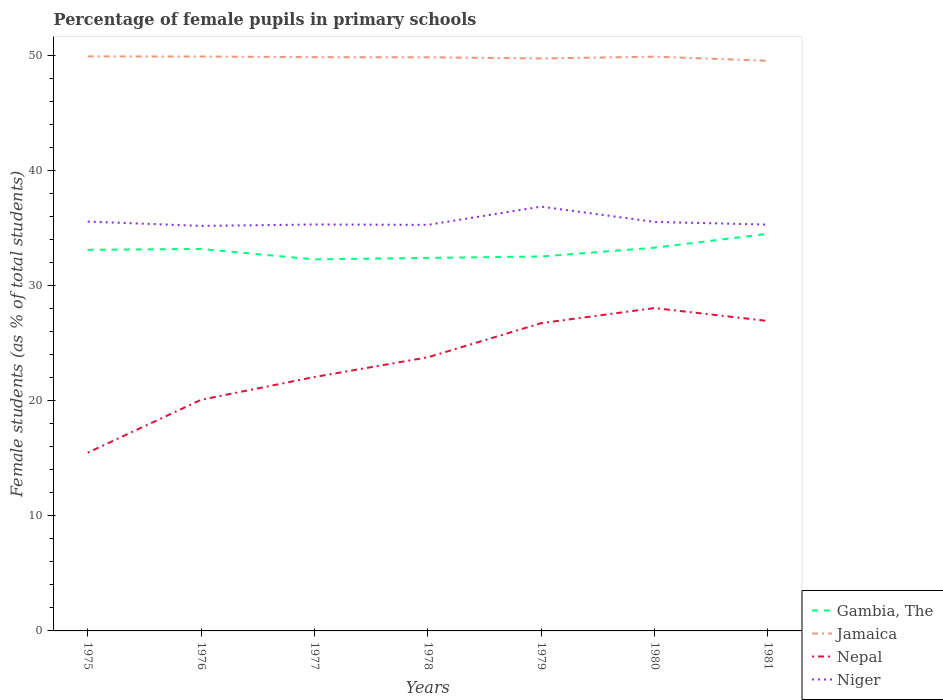Does the line corresponding to Jamaica intersect with the line corresponding to Gambia, The?
Give a very brief answer. No. Is the number of lines equal to the number of legend labels?
Make the answer very short. Yes. Across all years, what is the maximum percentage of female pupils in primary schools in Nepal?
Keep it short and to the point. 15.48. In which year was the percentage of female pupils in primary schools in Niger maximum?
Make the answer very short. 1976. What is the total percentage of female pupils in primary schools in Jamaica in the graph?
Keep it short and to the point. 0.32. What is the difference between the highest and the second highest percentage of female pupils in primary schools in Niger?
Your answer should be very brief. 1.67. How many lines are there?
Make the answer very short. 4. How many years are there in the graph?
Provide a short and direct response. 7. What is the difference between two consecutive major ticks on the Y-axis?
Your response must be concise. 10. Are the values on the major ticks of Y-axis written in scientific E-notation?
Give a very brief answer. No. How many legend labels are there?
Provide a succinct answer. 4. How are the legend labels stacked?
Give a very brief answer. Vertical. What is the title of the graph?
Give a very brief answer. Percentage of female pupils in primary schools. What is the label or title of the X-axis?
Give a very brief answer. Years. What is the label or title of the Y-axis?
Make the answer very short. Female students (as % of total students). What is the Female students (as % of total students) in Gambia, The in 1975?
Offer a very short reply. 33.11. What is the Female students (as % of total students) in Jamaica in 1975?
Provide a succinct answer. 49.91. What is the Female students (as % of total students) of Nepal in 1975?
Make the answer very short. 15.48. What is the Female students (as % of total students) in Niger in 1975?
Make the answer very short. 35.56. What is the Female students (as % of total students) in Gambia, The in 1976?
Provide a short and direct response. 33.18. What is the Female students (as % of total students) in Jamaica in 1976?
Provide a succinct answer. 49.9. What is the Female students (as % of total students) in Nepal in 1976?
Your answer should be compact. 20.08. What is the Female students (as % of total students) in Niger in 1976?
Keep it short and to the point. 35.19. What is the Female students (as % of total students) in Gambia, The in 1977?
Your answer should be compact. 32.28. What is the Female students (as % of total students) of Jamaica in 1977?
Provide a succinct answer. 49.85. What is the Female students (as % of total students) of Nepal in 1977?
Ensure brevity in your answer.  22.06. What is the Female students (as % of total students) in Niger in 1977?
Ensure brevity in your answer.  35.31. What is the Female students (as % of total students) of Gambia, The in 1978?
Provide a succinct answer. 32.41. What is the Female students (as % of total students) of Jamaica in 1978?
Offer a very short reply. 49.83. What is the Female students (as % of total students) of Nepal in 1978?
Keep it short and to the point. 23.77. What is the Female students (as % of total students) in Niger in 1978?
Make the answer very short. 35.28. What is the Female students (as % of total students) in Gambia, The in 1979?
Provide a short and direct response. 32.53. What is the Female students (as % of total students) of Jamaica in 1979?
Give a very brief answer. 49.73. What is the Female students (as % of total students) in Nepal in 1979?
Keep it short and to the point. 26.74. What is the Female students (as % of total students) of Niger in 1979?
Provide a succinct answer. 36.86. What is the Female students (as % of total students) of Gambia, The in 1980?
Keep it short and to the point. 33.29. What is the Female students (as % of total students) in Jamaica in 1980?
Provide a succinct answer. 49.89. What is the Female students (as % of total students) of Nepal in 1980?
Make the answer very short. 28.05. What is the Female students (as % of total students) in Niger in 1980?
Your response must be concise. 35.53. What is the Female students (as % of total students) of Gambia, The in 1981?
Your response must be concise. 34.5. What is the Female students (as % of total students) of Jamaica in 1981?
Keep it short and to the point. 49.53. What is the Female students (as % of total students) in Nepal in 1981?
Ensure brevity in your answer.  26.93. What is the Female students (as % of total students) of Niger in 1981?
Provide a succinct answer. 35.3. Across all years, what is the maximum Female students (as % of total students) in Gambia, The?
Provide a short and direct response. 34.5. Across all years, what is the maximum Female students (as % of total students) in Jamaica?
Offer a terse response. 49.91. Across all years, what is the maximum Female students (as % of total students) of Nepal?
Your answer should be compact. 28.05. Across all years, what is the maximum Female students (as % of total students) of Niger?
Give a very brief answer. 36.86. Across all years, what is the minimum Female students (as % of total students) in Gambia, The?
Your response must be concise. 32.28. Across all years, what is the minimum Female students (as % of total students) of Jamaica?
Offer a very short reply. 49.53. Across all years, what is the minimum Female students (as % of total students) of Nepal?
Provide a short and direct response. 15.48. Across all years, what is the minimum Female students (as % of total students) of Niger?
Provide a succinct answer. 35.19. What is the total Female students (as % of total students) in Gambia, The in the graph?
Your answer should be compact. 231.3. What is the total Female students (as % of total students) in Jamaica in the graph?
Make the answer very short. 348.64. What is the total Female students (as % of total students) of Nepal in the graph?
Offer a very short reply. 163.11. What is the total Female students (as % of total students) in Niger in the graph?
Keep it short and to the point. 249.03. What is the difference between the Female students (as % of total students) of Gambia, The in 1975 and that in 1976?
Ensure brevity in your answer.  -0.08. What is the difference between the Female students (as % of total students) of Jamaica in 1975 and that in 1976?
Give a very brief answer. 0.01. What is the difference between the Female students (as % of total students) in Nepal in 1975 and that in 1976?
Keep it short and to the point. -4.59. What is the difference between the Female students (as % of total students) in Niger in 1975 and that in 1976?
Your answer should be compact. 0.38. What is the difference between the Female students (as % of total students) of Gambia, The in 1975 and that in 1977?
Your answer should be very brief. 0.83. What is the difference between the Female students (as % of total students) in Jamaica in 1975 and that in 1977?
Your answer should be very brief. 0.06. What is the difference between the Female students (as % of total students) of Nepal in 1975 and that in 1977?
Keep it short and to the point. -6.57. What is the difference between the Female students (as % of total students) of Niger in 1975 and that in 1977?
Provide a short and direct response. 0.25. What is the difference between the Female students (as % of total students) of Gambia, The in 1975 and that in 1978?
Offer a terse response. 0.7. What is the difference between the Female students (as % of total students) of Jamaica in 1975 and that in 1978?
Provide a succinct answer. 0.08. What is the difference between the Female students (as % of total students) of Nepal in 1975 and that in 1978?
Keep it short and to the point. -8.29. What is the difference between the Female students (as % of total students) of Niger in 1975 and that in 1978?
Make the answer very short. 0.29. What is the difference between the Female students (as % of total students) of Gambia, The in 1975 and that in 1979?
Give a very brief answer. 0.58. What is the difference between the Female students (as % of total students) of Jamaica in 1975 and that in 1979?
Make the answer very short. 0.18. What is the difference between the Female students (as % of total students) in Nepal in 1975 and that in 1979?
Your answer should be very brief. -11.25. What is the difference between the Female students (as % of total students) in Niger in 1975 and that in 1979?
Offer a terse response. -1.3. What is the difference between the Female students (as % of total students) of Gambia, The in 1975 and that in 1980?
Keep it short and to the point. -0.18. What is the difference between the Female students (as % of total students) of Jamaica in 1975 and that in 1980?
Make the answer very short. 0.02. What is the difference between the Female students (as % of total students) of Nepal in 1975 and that in 1980?
Give a very brief answer. -12.56. What is the difference between the Female students (as % of total students) in Niger in 1975 and that in 1980?
Provide a succinct answer. 0.03. What is the difference between the Female students (as % of total students) in Gambia, The in 1975 and that in 1981?
Provide a short and direct response. -1.39. What is the difference between the Female students (as % of total students) of Jamaica in 1975 and that in 1981?
Keep it short and to the point. 0.38. What is the difference between the Female students (as % of total students) of Nepal in 1975 and that in 1981?
Provide a short and direct response. -11.44. What is the difference between the Female students (as % of total students) of Niger in 1975 and that in 1981?
Keep it short and to the point. 0.26. What is the difference between the Female students (as % of total students) in Gambia, The in 1976 and that in 1977?
Ensure brevity in your answer.  0.91. What is the difference between the Female students (as % of total students) in Jamaica in 1976 and that in 1977?
Provide a succinct answer. 0.05. What is the difference between the Female students (as % of total students) in Nepal in 1976 and that in 1977?
Ensure brevity in your answer.  -1.98. What is the difference between the Female students (as % of total students) of Niger in 1976 and that in 1977?
Your response must be concise. -0.12. What is the difference between the Female students (as % of total students) in Gambia, The in 1976 and that in 1978?
Give a very brief answer. 0.78. What is the difference between the Female students (as % of total students) of Jamaica in 1976 and that in 1978?
Offer a terse response. 0.07. What is the difference between the Female students (as % of total students) of Nepal in 1976 and that in 1978?
Offer a very short reply. -3.69. What is the difference between the Female students (as % of total students) of Niger in 1976 and that in 1978?
Make the answer very short. -0.09. What is the difference between the Female students (as % of total students) in Gambia, The in 1976 and that in 1979?
Ensure brevity in your answer.  0.65. What is the difference between the Female students (as % of total students) in Jamaica in 1976 and that in 1979?
Your response must be concise. 0.17. What is the difference between the Female students (as % of total students) of Nepal in 1976 and that in 1979?
Ensure brevity in your answer.  -6.66. What is the difference between the Female students (as % of total students) in Niger in 1976 and that in 1979?
Ensure brevity in your answer.  -1.67. What is the difference between the Female students (as % of total students) of Gambia, The in 1976 and that in 1980?
Your answer should be compact. -0.11. What is the difference between the Female students (as % of total students) in Jamaica in 1976 and that in 1980?
Your response must be concise. 0.01. What is the difference between the Female students (as % of total students) in Nepal in 1976 and that in 1980?
Give a very brief answer. -7.97. What is the difference between the Female students (as % of total students) in Niger in 1976 and that in 1980?
Make the answer very short. -0.35. What is the difference between the Female students (as % of total students) in Gambia, The in 1976 and that in 1981?
Your answer should be very brief. -1.32. What is the difference between the Female students (as % of total students) of Jamaica in 1976 and that in 1981?
Ensure brevity in your answer.  0.37. What is the difference between the Female students (as % of total students) in Nepal in 1976 and that in 1981?
Offer a very short reply. -6.85. What is the difference between the Female students (as % of total students) in Niger in 1976 and that in 1981?
Ensure brevity in your answer.  -0.11. What is the difference between the Female students (as % of total students) in Gambia, The in 1977 and that in 1978?
Provide a short and direct response. -0.13. What is the difference between the Female students (as % of total students) of Jamaica in 1977 and that in 1978?
Ensure brevity in your answer.  0.01. What is the difference between the Female students (as % of total students) in Nepal in 1977 and that in 1978?
Provide a succinct answer. -1.71. What is the difference between the Female students (as % of total students) in Niger in 1977 and that in 1978?
Offer a terse response. 0.03. What is the difference between the Female students (as % of total students) of Gambia, The in 1977 and that in 1979?
Your answer should be very brief. -0.25. What is the difference between the Female students (as % of total students) of Jamaica in 1977 and that in 1979?
Your answer should be compact. 0.12. What is the difference between the Female students (as % of total students) of Nepal in 1977 and that in 1979?
Ensure brevity in your answer.  -4.68. What is the difference between the Female students (as % of total students) of Niger in 1977 and that in 1979?
Your answer should be very brief. -1.55. What is the difference between the Female students (as % of total students) of Gambia, The in 1977 and that in 1980?
Keep it short and to the point. -1.01. What is the difference between the Female students (as % of total students) in Jamaica in 1977 and that in 1980?
Make the answer very short. -0.04. What is the difference between the Female students (as % of total students) of Nepal in 1977 and that in 1980?
Make the answer very short. -5.99. What is the difference between the Female students (as % of total students) in Niger in 1977 and that in 1980?
Provide a short and direct response. -0.22. What is the difference between the Female students (as % of total students) of Gambia, The in 1977 and that in 1981?
Ensure brevity in your answer.  -2.22. What is the difference between the Female students (as % of total students) in Jamaica in 1977 and that in 1981?
Provide a short and direct response. 0.32. What is the difference between the Female students (as % of total students) in Nepal in 1977 and that in 1981?
Give a very brief answer. -4.87. What is the difference between the Female students (as % of total students) of Niger in 1977 and that in 1981?
Offer a terse response. 0.01. What is the difference between the Female students (as % of total students) of Gambia, The in 1978 and that in 1979?
Keep it short and to the point. -0.12. What is the difference between the Female students (as % of total students) in Jamaica in 1978 and that in 1979?
Ensure brevity in your answer.  0.1. What is the difference between the Female students (as % of total students) of Nepal in 1978 and that in 1979?
Offer a very short reply. -2.97. What is the difference between the Female students (as % of total students) of Niger in 1978 and that in 1979?
Provide a short and direct response. -1.59. What is the difference between the Female students (as % of total students) in Gambia, The in 1978 and that in 1980?
Your answer should be very brief. -0.89. What is the difference between the Female students (as % of total students) in Jamaica in 1978 and that in 1980?
Make the answer very short. -0.06. What is the difference between the Female students (as % of total students) in Nepal in 1978 and that in 1980?
Give a very brief answer. -4.28. What is the difference between the Female students (as % of total students) of Niger in 1978 and that in 1980?
Your answer should be very brief. -0.26. What is the difference between the Female students (as % of total students) in Gambia, The in 1978 and that in 1981?
Provide a succinct answer. -2.09. What is the difference between the Female students (as % of total students) of Jamaica in 1978 and that in 1981?
Your answer should be very brief. 0.3. What is the difference between the Female students (as % of total students) in Nepal in 1978 and that in 1981?
Give a very brief answer. -3.15. What is the difference between the Female students (as % of total students) in Niger in 1978 and that in 1981?
Your answer should be compact. -0.02. What is the difference between the Female students (as % of total students) in Gambia, The in 1979 and that in 1980?
Your answer should be very brief. -0.76. What is the difference between the Female students (as % of total students) of Jamaica in 1979 and that in 1980?
Offer a terse response. -0.16. What is the difference between the Female students (as % of total students) of Nepal in 1979 and that in 1980?
Your response must be concise. -1.31. What is the difference between the Female students (as % of total students) of Niger in 1979 and that in 1980?
Your answer should be compact. 1.33. What is the difference between the Female students (as % of total students) of Gambia, The in 1979 and that in 1981?
Provide a succinct answer. -1.97. What is the difference between the Female students (as % of total students) in Jamaica in 1979 and that in 1981?
Offer a very short reply. 0.2. What is the difference between the Female students (as % of total students) of Nepal in 1979 and that in 1981?
Provide a succinct answer. -0.19. What is the difference between the Female students (as % of total students) of Niger in 1979 and that in 1981?
Your answer should be compact. 1.56. What is the difference between the Female students (as % of total students) of Gambia, The in 1980 and that in 1981?
Ensure brevity in your answer.  -1.21. What is the difference between the Female students (as % of total students) in Jamaica in 1980 and that in 1981?
Make the answer very short. 0.36. What is the difference between the Female students (as % of total students) in Nepal in 1980 and that in 1981?
Offer a very short reply. 1.12. What is the difference between the Female students (as % of total students) of Niger in 1980 and that in 1981?
Your answer should be compact. 0.23. What is the difference between the Female students (as % of total students) of Gambia, The in 1975 and the Female students (as % of total students) of Jamaica in 1976?
Ensure brevity in your answer.  -16.79. What is the difference between the Female students (as % of total students) in Gambia, The in 1975 and the Female students (as % of total students) in Nepal in 1976?
Your response must be concise. 13.03. What is the difference between the Female students (as % of total students) in Gambia, The in 1975 and the Female students (as % of total students) in Niger in 1976?
Your answer should be compact. -2.08. What is the difference between the Female students (as % of total students) of Jamaica in 1975 and the Female students (as % of total students) of Nepal in 1976?
Your answer should be very brief. 29.83. What is the difference between the Female students (as % of total students) in Jamaica in 1975 and the Female students (as % of total students) in Niger in 1976?
Ensure brevity in your answer.  14.73. What is the difference between the Female students (as % of total students) in Nepal in 1975 and the Female students (as % of total students) in Niger in 1976?
Provide a short and direct response. -19.7. What is the difference between the Female students (as % of total students) of Gambia, The in 1975 and the Female students (as % of total students) of Jamaica in 1977?
Keep it short and to the point. -16.74. What is the difference between the Female students (as % of total students) of Gambia, The in 1975 and the Female students (as % of total students) of Nepal in 1977?
Provide a succinct answer. 11.05. What is the difference between the Female students (as % of total students) of Gambia, The in 1975 and the Female students (as % of total students) of Niger in 1977?
Provide a succinct answer. -2.2. What is the difference between the Female students (as % of total students) in Jamaica in 1975 and the Female students (as % of total students) in Nepal in 1977?
Your answer should be compact. 27.85. What is the difference between the Female students (as % of total students) of Jamaica in 1975 and the Female students (as % of total students) of Niger in 1977?
Offer a very short reply. 14.6. What is the difference between the Female students (as % of total students) of Nepal in 1975 and the Female students (as % of total students) of Niger in 1977?
Give a very brief answer. -19.82. What is the difference between the Female students (as % of total students) in Gambia, The in 1975 and the Female students (as % of total students) in Jamaica in 1978?
Provide a succinct answer. -16.73. What is the difference between the Female students (as % of total students) of Gambia, The in 1975 and the Female students (as % of total students) of Nepal in 1978?
Offer a very short reply. 9.34. What is the difference between the Female students (as % of total students) of Gambia, The in 1975 and the Female students (as % of total students) of Niger in 1978?
Offer a terse response. -2.17. What is the difference between the Female students (as % of total students) of Jamaica in 1975 and the Female students (as % of total students) of Nepal in 1978?
Offer a terse response. 26.14. What is the difference between the Female students (as % of total students) in Jamaica in 1975 and the Female students (as % of total students) in Niger in 1978?
Offer a terse response. 14.64. What is the difference between the Female students (as % of total students) of Nepal in 1975 and the Female students (as % of total students) of Niger in 1978?
Your response must be concise. -19.79. What is the difference between the Female students (as % of total students) of Gambia, The in 1975 and the Female students (as % of total students) of Jamaica in 1979?
Make the answer very short. -16.62. What is the difference between the Female students (as % of total students) of Gambia, The in 1975 and the Female students (as % of total students) of Nepal in 1979?
Provide a short and direct response. 6.37. What is the difference between the Female students (as % of total students) of Gambia, The in 1975 and the Female students (as % of total students) of Niger in 1979?
Ensure brevity in your answer.  -3.75. What is the difference between the Female students (as % of total students) of Jamaica in 1975 and the Female students (as % of total students) of Nepal in 1979?
Your response must be concise. 23.17. What is the difference between the Female students (as % of total students) of Jamaica in 1975 and the Female students (as % of total students) of Niger in 1979?
Give a very brief answer. 13.05. What is the difference between the Female students (as % of total students) in Nepal in 1975 and the Female students (as % of total students) in Niger in 1979?
Offer a very short reply. -21.38. What is the difference between the Female students (as % of total students) in Gambia, The in 1975 and the Female students (as % of total students) in Jamaica in 1980?
Your answer should be very brief. -16.78. What is the difference between the Female students (as % of total students) in Gambia, The in 1975 and the Female students (as % of total students) in Nepal in 1980?
Your answer should be very brief. 5.06. What is the difference between the Female students (as % of total students) in Gambia, The in 1975 and the Female students (as % of total students) in Niger in 1980?
Make the answer very short. -2.42. What is the difference between the Female students (as % of total students) of Jamaica in 1975 and the Female students (as % of total students) of Nepal in 1980?
Your answer should be very brief. 21.87. What is the difference between the Female students (as % of total students) of Jamaica in 1975 and the Female students (as % of total students) of Niger in 1980?
Give a very brief answer. 14.38. What is the difference between the Female students (as % of total students) in Nepal in 1975 and the Female students (as % of total students) in Niger in 1980?
Offer a very short reply. -20.05. What is the difference between the Female students (as % of total students) of Gambia, The in 1975 and the Female students (as % of total students) of Jamaica in 1981?
Your answer should be very brief. -16.42. What is the difference between the Female students (as % of total students) of Gambia, The in 1975 and the Female students (as % of total students) of Nepal in 1981?
Keep it short and to the point. 6.18. What is the difference between the Female students (as % of total students) of Gambia, The in 1975 and the Female students (as % of total students) of Niger in 1981?
Give a very brief answer. -2.19. What is the difference between the Female students (as % of total students) in Jamaica in 1975 and the Female students (as % of total students) in Nepal in 1981?
Keep it short and to the point. 22.99. What is the difference between the Female students (as % of total students) in Jamaica in 1975 and the Female students (as % of total students) in Niger in 1981?
Your answer should be compact. 14.61. What is the difference between the Female students (as % of total students) in Nepal in 1975 and the Female students (as % of total students) in Niger in 1981?
Provide a short and direct response. -19.81. What is the difference between the Female students (as % of total students) of Gambia, The in 1976 and the Female students (as % of total students) of Jamaica in 1977?
Offer a terse response. -16.66. What is the difference between the Female students (as % of total students) in Gambia, The in 1976 and the Female students (as % of total students) in Nepal in 1977?
Your response must be concise. 11.13. What is the difference between the Female students (as % of total students) in Gambia, The in 1976 and the Female students (as % of total students) in Niger in 1977?
Keep it short and to the point. -2.13. What is the difference between the Female students (as % of total students) in Jamaica in 1976 and the Female students (as % of total students) in Nepal in 1977?
Provide a short and direct response. 27.84. What is the difference between the Female students (as % of total students) in Jamaica in 1976 and the Female students (as % of total students) in Niger in 1977?
Provide a succinct answer. 14.59. What is the difference between the Female students (as % of total students) in Nepal in 1976 and the Female students (as % of total students) in Niger in 1977?
Make the answer very short. -15.23. What is the difference between the Female students (as % of total students) of Gambia, The in 1976 and the Female students (as % of total students) of Jamaica in 1978?
Provide a succinct answer. -16.65. What is the difference between the Female students (as % of total students) of Gambia, The in 1976 and the Female students (as % of total students) of Nepal in 1978?
Give a very brief answer. 9.41. What is the difference between the Female students (as % of total students) of Gambia, The in 1976 and the Female students (as % of total students) of Niger in 1978?
Your answer should be compact. -2.09. What is the difference between the Female students (as % of total students) in Jamaica in 1976 and the Female students (as % of total students) in Nepal in 1978?
Ensure brevity in your answer.  26.13. What is the difference between the Female students (as % of total students) in Jamaica in 1976 and the Female students (as % of total students) in Niger in 1978?
Your response must be concise. 14.62. What is the difference between the Female students (as % of total students) in Nepal in 1976 and the Female students (as % of total students) in Niger in 1978?
Offer a very short reply. -15.2. What is the difference between the Female students (as % of total students) of Gambia, The in 1976 and the Female students (as % of total students) of Jamaica in 1979?
Offer a terse response. -16.55. What is the difference between the Female students (as % of total students) of Gambia, The in 1976 and the Female students (as % of total students) of Nepal in 1979?
Provide a short and direct response. 6.45. What is the difference between the Female students (as % of total students) of Gambia, The in 1976 and the Female students (as % of total students) of Niger in 1979?
Your response must be concise. -3.68. What is the difference between the Female students (as % of total students) in Jamaica in 1976 and the Female students (as % of total students) in Nepal in 1979?
Make the answer very short. 23.16. What is the difference between the Female students (as % of total students) of Jamaica in 1976 and the Female students (as % of total students) of Niger in 1979?
Your answer should be very brief. 13.04. What is the difference between the Female students (as % of total students) of Nepal in 1976 and the Female students (as % of total students) of Niger in 1979?
Your answer should be very brief. -16.78. What is the difference between the Female students (as % of total students) in Gambia, The in 1976 and the Female students (as % of total students) in Jamaica in 1980?
Give a very brief answer. -16.7. What is the difference between the Female students (as % of total students) of Gambia, The in 1976 and the Female students (as % of total students) of Nepal in 1980?
Ensure brevity in your answer.  5.14. What is the difference between the Female students (as % of total students) in Gambia, The in 1976 and the Female students (as % of total students) in Niger in 1980?
Provide a short and direct response. -2.35. What is the difference between the Female students (as % of total students) of Jamaica in 1976 and the Female students (as % of total students) of Nepal in 1980?
Offer a terse response. 21.85. What is the difference between the Female students (as % of total students) in Jamaica in 1976 and the Female students (as % of total students) in Niger in 1980?
Make the answer very short. 14.37. What is the difference between the Female students (as % of total students) in Nepal in 1976 and the Female students (as % of total students) in Niger in 1980?
Your response must be concise. -15.45. What is the difference between the Female students (as % of total students) of Gambia, The in 1976 and the Female students (as % of total students) of Jamaica in 1981?
Provide a short and direct response. -16.35. What is the difference between the Female students (as % of total students) of Gambia, The in 1976 and the Female students (as % of total students) of Nepal in 1981?
Offer a very short reply. 6.26. What is the difference between the Female students (as % of total students) in Gambia, The in 1976 and the Female students (as % of total students) in Niger in 1981?
Provide a succinct answer. -2.11. What is the difference between the Female students (as % of total students) in Jamaica in 1976 and the Female students (as % of total students) in Nepal in 1981?
Provide a succinct answer. 22.97. What is the difference between the Female students (as % of total students) of Jamaica in 1976 and the Female students (as % of total students) of Niger in 1981?
Give a very brief answer. 14.6. What is the difference between the Female students (as % of total students) in Nepal in 1976 and the Female students (as % of total students) in Niger in 1981?
Give a very brief answer. -15.22. What is the difference between the Female students (as % of total students) in Gambia, The in 1977 and the Female students (as % of total students) in Jamaica in 1978?
Your answer should be very brief. -17.56. What is the difference between the Female students (as % of total students) in Gambia, The in 1977 and the Female students (as % of total students) in Nepal in 1978?
Make the answer very short. 8.51. What is the difference between the Female students (as % of total students) of Gambia, The in 1977 and the Female students (as % of total students) of Niger in 1978?
Ensure brevity in your answer.  -3. What is the difference between the Female students (as % of total students) in Jamaica in 1977 and the Female students (as % of total students) in Nepal in 1978?
Your answer should be very brief. 26.08. What is the difference between the Female students (as % of total students) of Jamaica in 1977 and the Female students (as % of total students) of Niger in 1978?
Offer a terse response. 14.57. What is the difference between the Female students (as % of total students) of Nepal in 1977 and the Female students (as % of total students) of Niger in 1978?
Offer a terse response. -13.22. What is the difference between the Female students (as % of total students) in Gambia, The in 1977 and the Female students (as % of total students) in Jamaica in 1979?
Offer a very short reply. -17.45. What is the difference between the Female students (as % of total students) of Gambia, The in 1977 and the Female students (as % of total students) of Nepal in 1979?
Keep it short and to the point. 5.54. What is the difference between the Female students (as % of total students) in Gambia, The in 1977 and the Female students (as % of total students) in Niger in 1979?
Give a very brief answer. -4.58. What is the difference between the Female students (as % of total students) in Jamaica in 1977 and the Female students (as % of total students) in Nepal in 1979?
Offer a terse response. 23.11. What is the difference between the Female students (as % of total students) of Jamaica in 1977 and the Female students (as % of total students) of Niger in 1979?
Make the answer very short. 12.99. What is the difference between the Female students (as % of total students) of Nepal in 1977 and the Female students (as % of total students) of Niger in 1979?
Make the answer very short. -14.8. What is the difference between the Female students (as % of total students) of Gambia, The in 1977 and the Female students (as % of total students) of Jamaica in 1980?
Provide a short and direct response. -17.61. What is the difference between the Female students (as % of total students) of Gambia, The in 1977 and the Female students (as % of total students) of Nepal in 1980?
Your response must be concise. 4.23. What is the difference between the Female students (as % of total students) in Gambia, The in 1977 and the Female students (as % of total students) in Niger in 1980?
Make the answer very short. -3.25. What is the difference between the Female students (as % of total students) of Jamaica in 1977 and the Female students (as % of total students) of Nepal in 1980?
Your response must be concise. 21.8. What is the difference between the Female students (as % of total students) of Jamaica in 1977 and the Female students (as % of total students) of Niger in 1980?
Keep it short and to the point. 14.32. What is the difference between the Female students (as % of total students) in Nepal in 1977 and the Female students (as % of total students) in Niger in 1980?
Provide a succinct answer. -13.47. What is the difference between the Female students (as % of total students) of Gambia, The in 1977 and the Female students (as % of total students) of Jamaica in 1981?
Your response must be concise. -17.25. What is the difference between the Female students (as % of total students) of Gambia, The in 1977 and the Female students (as % of total students) of Nepal in 1981?
Ensure brevity in your answer.  5.35. What is the difference between the Female students (as % of total students) of Gambia, The in 1977 and the Female students (as % of total students) of Niger in 1981?
Make the answer very short. -3.02. What is the difference between the Female students (as % of total students) of Jamaica in 1977 and the Female students (as % of total students) of Nepal in 1981?
Offer a very short reply. 22.92. What is the difference between the Female students (as % of total students) in Jamaica in 1977 and the Female students (as % of total students) in Niger in 1981?
Offer a very short reply. 14.55. What is the difference between the Female students (as % of total students) in Nepal in 1977 and the Female students (as % of total students) in Niger in 1981?
Your response must be concise. -13.24. What is the difference between the Female students (as % of total students) of Gambia, The in 1978 and the Female students (as % of total students) of Jamaica in 1979?
Your response must be concise. -17.32. What is the difference between the Female students (as % of total students) of Gambia, The in 1978 and the Female students (as % of total students) of Nepal in 1979?
Your answer should be very brief. 5.67. What is the difference between the Female students (as % of total students) in Gambia, The in 1978 and the Female students (as % of total students) in Niger in 1979?
Ensure brevity in your answer.  -4.46. What is the difference between the Female students (as % of total students) in Jamaica in 1978 and the Female students (as % of total students) in Nepal in 1979?
Provide a succinct answer. 23.09. What is the difference between the Female students (as % of total students) of Jamaica in 1978 and the Female students (as % of total students) of Niger in 1979?
Your response must be concise. 12.97. What is the difference between the Female students (as % of total students) in Nepal in 1978 and the Female students (as % of total students) in Niger in 1979?
Your response must be concise. -13.09. What is the difference between the Female students (as % of total students) in Gambia, The in 1978 and the Female students (as % of total students) in Jamaica in 1980?
Offer a terse response. -17.48. What is the difference between the Female students (as % of total students) of Gambia, The in 1978 and the Female students (as % of total students) of Nepal in 1980?
Provide a short and direct response. 4.36. What is the difference between the Female students (as % of total students) in Gambia, The in 1978 and the Female students (as % of total students) in Niger in 1980?
Provide a succinct answer. -3.13. What is the difference between the Female students (as % of total students) of Jamaica in 1978 and the Female students (as % of total students) of Nepal in 1980?
Your answer should be compact. 21.79. What is the difference between the Female students (as % of total students) of Jamaica in 1978 and the Female students (as % of total students) of Niger in 1980?
Offer a terse response. 14.3. What is the difference between the Female students (as % of total students) of Nepal in 1978 and the Female students (as % of total students) of Niger in 1980?
Ensure brevity in your answer.  -11.76. What is the difference between the Female students (as % of total students) of Gambia, The in 1978 and the Female students (as % of total students) of Jamaica in 1981?
Provide a short and direct response. -17.12. What is the difference between the Female students (as % of total students) of Gambia, The in 1978 and the Female students (as % of total students) of Nepal in 1981?
Your answer should be very brief. 5.48. What is the difference between the Female students (as % of total students) in Gambia, The in 1978 and the Female students (as % of total students) in Niger in 1981?
Keep it short and to the point. -2.89. What is the difference between the Female students (as % of total students) of Jamaica in 1978 and the Female students (as % of total students) of Nepal in 1981?
Your response must be concise. 22.91. What is the difference between the Female students (as % of total students) in Jamaica in 1978 and the Female students (as % of total students) in Niger in 1981?
Provide a succinct answer. 14.53. What is the difference between the Female students (as % of total students) in Nepal in 1978 and the Female students (as % of total students) in Niger in 1981?
Ensure brevity in your answer.  -11.53. What is the difference between the Female students (as % of total students) of Gambia, The in 1979 and the Female students (as % of total students) of Jamaica in 1980?
Offer a terse response. -17.36. What is the difference between the Female students (as % of total students) in Gambia, The in 1979 and the Female students (as % of total students) in Nepal in 1980?
Provide a succinct answer. 4.48. What is the difference between the Female students (as % of total students) of Gambia, The in 1979 and the Female students (as % of total students) of Niger in 1980?
Make the answer very short. -3. What is the difference between the Female students (as % of total students) of Jamaica in 1979 and the Female students (as % of total students) of Nepal in 1980?
Make the answer very short. 21.68. What is the difference between the Female students (as % of total students) in Jamaica in 1979 and the Female students (as % of total students) in Niger in 1980?
Make the answer very short. 14.2. What is the difference between the Female students (as % of total students) of Nepal in 1979 and the Female students (as % of total students) of Niger in 1980?
Ensure brevity in your answer.  -8.79. What is the difference between the Female students (as % of total students) of Gambia, The in 1979 and the Female students (as % of total students) of Jamaica in 1981?
Your answer should be very brief. -17. What is the difference between the Female students (as % of total students) of Gambia, The in 1979 and the Female students (as % of total students) of Nepal in 1981?
Your answer should be very brief. 5.6. What is the difference between the Female students (as % of total students) of Gambia, The in 1979 and the Female students (as % of total students) of Niger in 1981?
Keep it short and to the point. -2.77. What is the difference between the Female students (as % of total students) of Jamaica in 1979 and the Female students (as % of total students) of Nepal in 1981?
Provide a short and direct response. 22.8. What is the difference between the Female students (as % of total students) of Jamaica in 1979 and the Female students (as % of total students) of Niger in 1981?
Provide a short and direct response. 14.43. What is the difference between the Female students (as % of total students) in Nepal in 1979 and the Female students (as % of total students) in Niger in 1981?
Provide a succinct answer. -8.56. What is the difference between the Female students (as % of total students) of Gambia, The in 1980 and the Female students (as % of total students) of Jamaica in 1981?
Make the answer very short. -16.24. What is the difference between the Female students (as % of total students) of Gambia, The in 1980 and the Female students (as % of total students) of Nepal in 1981?
Give a very brief answer. 6.37. What is the difference between the Female students (as % of total students) in Gambia, The in 1980 and the Female students (as % of total students) in Niger in 1981?
Your answer should be very brief. -2.01. What is the difference between the Female students (as % of total students) of Jamaica in 1980 and the Female students (as % of total students) of Nepal in 1981?
Offer a terse response. 22.96. What is the difference between the Female students (as % of total students) of Jamaica in 1980 and the Female students (as % of total students) of Niger in 1981?
Give a very brief answer. 14.59. What is the difference between the Female students (as % of total students) in Nepal in 1980 and the Female students (as % of total students) in Niger in 1981?
Your answer should be compact. -7.25. What is the average Female students (as % of total students) in Gambia, The per year?
Offer a terse response. 33.04. What is the average Female students (as % of total students) in Jamaica per year?
Offer a very short reply. 49.81. What is the average Female students (as % of total students) in Nepal per year?
Your answer should be very brief. 23.3. What is the average Female students (as % of total students) in Niger per year?
Make the answer very short. 35.58. In the year 1975, what is the difference between the Female students (as % of total students) in Gambia, The and Female students (as % of total students) in Jamaica?
Offer a very short reply. -16.8. In the year 1975, what is the difference between the Female students (as % of total students) of Gambia, The and Female students (as % of total students) of Nepal?
Make the answer very short. 17.62. In the year 1975, what is the difference between the Female students (as % of total students) of Gambia, The and Female students (as % of total students) of Niger?
Your response must be concise. -2.45. In the year 1975, what is the difference between the Female students (as % of total students) of Jamaica and Female students (as % of total students) of Nepal?
Offer a terse response. 34.43. In the year 1975, what is the difference between the Female students (as % of total students) in Jamaica and Female students (as % of total students) in Niger?
Your answer should be very brief. 14.35. In the year 1975, what is the difference between the Female students (as % of total students) of Nepal and Female students (as % of total students) of Niger?
Provide a succinct answer. -20.08. In the year 1976, what is the difference between the Female students (as % of total students) of Gambia, The and Female students (as % of total students) of Jamaica?
Keep it short and to the point. -16.72. In the year 1976, what is the difference between the Female students (as % of total students) of Gambia, The and Female students (as % of total students) of Nepal?
Your answer should be very brief. 13.11. In the year 1976, what is the difference between the Female students (as % of total students) of Gambia, The and Female students (as % of total students) of Niger?
Offer a very short reply. -2. In the year 1976, what is the difference between the Female students (as % of total students) of Jamaica and Female students (as % of total students) of Nepal?
Provide a short and direct response. 29.82. In the year 1976, what is the difference between the Female students (as % of total students) of Jamaica and Female students (as % of total students) of Niger?
Provide a succinct answer. 14.71. In the year 1976, what is the difference between the Female students (as % of total students) of Nepal and Female students (as % of total students) of Niger?
Give a very brief answer. -15.11. In the year 1977, what is the difference between the Female students (as % of total students) of Gambia, The and Female students (as % of total students) of Jamaica?
Offer a very short reply. -17.57. In the year 1977, what is the difference between the Female students (as % of total students) in Gambia, The and Female students (as % of total students) in Nepal?
Your response must be concise. 10.22. In the year 1977, what is the difference between the Female students (as % of total students) in Gambia, The and Female students (as % of total students) in Niger?
Your answer should be very brief. -3.03. In the year 1977, what is the difference between the Female students (as % of total students) of Jamaica and Female students (as % of total students) of Nepal?
Make the answer very short. 27.79. In the year 1977, what is the difference between the Female students (as % of total students) in Jamaica and Female students (as % of total students) in Niger?
Your response must be concise. 14.54. In the year 1977, what is the difference between the Female students (as % of total students) in Nepal and Female students (as % of total students) in Niger?
Provide a succinct answer. -13.25. In the year 1978, what is the difference between the Female students (as % of total students) in Gambia, The and Female students (as % of total students) in Jamaica?
Offer a terse response. -17.43. In the year 1978, what is the difference between the Female students (as % of total students) in Gambia, The and Female students (as % of total students) in Nepal?
Provide a short and direct response. 8.63. In the year 1978, what is the difference between the Female students (as % of total students) of Gambia, The and Female students (as % of total students) of Niger?
Give a very brief answer. -2.87. In the year 1978, what is the difference between the Female students (as % of total students) in Jamaica and Female students (as % of total students) in Nepal?
Keep it short and to the point. 26.06. In the year 1978, what is the difference between the Female students (as % of total students) of Jamaica and Female students (as % of total students) of Niger?
Provide a short and direct response. 14.56. In the year 1978, what is the difference between the Female students (as % of total students) in Nepal and Female students (as % of total students) in Niger?
Your answer should be compact. -11.5. In the year 1979, what is the difference between the Female students (as % of total students) in Gambia, The and Female students (as % of total students) in Jamaica?
Make the answer very short. -17.2. In the year 1979, what is the difference between the Female students (as % of total students) in Gambia, The and Female students (as % of total students) in Nepal?
Your answer should be compact. 5.79. In the year 1979, what is the difference between the Female students (as % of total students) in Gambia, The and Female students (as % of total students) in Niger?
Offer a very short reply. -4.33. In the year 1979, what is the difference between the Female students (as % of total students) in Jamaica and Female students (as % of total students) in Nepal?
Your answer should be very brief. 22.99. In the year 1979, what is the difference between the Female students (as % of total students) in Jamaica and Female students (as % of total students) in Niger?
Offer a terse response. 12.87. In the year 1979, what is the difference between the Female students (as % of total students) in Nepal and Female students (as % of total students) in Niger?
Offer a very short reply. -10.12. In the year 1980, what is the difference between the Female students (as % of total students) of Gambia, The and Female students (as % of total students) of Jamaica?
Keep it short and to the point. -16.6. In the year 1980, what is the difference between the Female students (as % of total students) of Gambia, The and Female students (as % of total students) of Nepal?
Your answer should be compact. 5.25. In the year 1980, what is the difference between the Female students (as % of total students) of Gambia, The and Female students (as % of total students) of Niger?
Your answer should be compact. -2.24. In the year 1980, what is the difference between the Female students (as % of total students) of Jamaica and Female students (as % of total students) of Nepal?
Offer a terse response. 21.84. In the year 1980, what is the difference between the Female students (as % of total students) in Jamaica and Female students (as % of total students) in Niger?
Ensure brevity in your answer.  14.36. In the year 1980, what is the difference between the Female students (as % of total students) in Nepal and Female students (as % of total students) in Niger?
Your response must be concise. -7.49. In the year 1981, what is the difference between the Female students (as % of total students) in Gambia, The and Female students (as % of total students) in Jamaica?
Offer a very short reply. -15.03. In the year 1981, what is the difference between the Female students (as % of total students) in Gambia, The and Female students (as % of total students) in Nepal?
Give a very brief answer. 7.57. In the year 1981, what is the difference between the Female students (as % of total students) in Gambia, The and Female students (as % of total students) in Niger?
Your response must be concise. -0.8. In the year 1981, what is the difference between the Female students (as % of total students) in Jamaica and Female students (as % of total students) in Nepal?
Give a very brief answer. 22.6. In the year 1981, what is the difference between the Female students (as % of total students) in Jamaica and Female students (as % of total students) in Niger?
Keep it short and to the point. 14.23. In the year 1981, what is the difference between the Female students (as % of total students) of Nepal and Female students (as % of total students) of Niger?
Your answer should be very brief. -8.37. What is the ratio of the Female students (as % of total students) in Nepal in 1975 to that in 1976?
Offer a very short reply. 0.77. What is the ratio of the Female students (as % of total students) in Niger in 1975 to that in 1976?
Your answer should be very brief. 1.01. What is the ratio of the Female students (as % of total students) in Gambia, The in 1975 to that in 1977?
Ensure brevity in your answer.  1.03. What is the ratio of the Female students (as % of total students) of Nepal in 1975 to that in 1977?
Give a very brief answer. 0.7. What is the ratio of the Female students (as % of total students) of Niger in 1975 to that in 1977?
Provide a succinct answer. 1.01. What is the ratio of the Female students (as % of total students) in Gambia, The in 1975 to that in 1978?
Offer a terse response. 1.02. What is the ratio of the Female students (as % of total students) of Jamaica in 1975 to that in 1978?
Your answer should be very brief. 1. What is the ratio of the Female students (as % of total students) of Nepal in 1975 to that in 1978?
Provide a succinct answer. 0.65. What is the ratio of the Female students (as % of total students) of Niger in 1975 to that in 1978?
Ensure brevity in your answer.  1.01. What is the ratio of the Female students (as % of total students) in Gambia, The in 1975 to that in 1979?
Offer a very short reply. 1.02. What is the ratio of the Female students (as % of total students) in Nepal in 1975 to that in 1979?
Offer a terse response. 0.58. What is the ratio of the Female students (as % of total students) in Niger in 1975 to that in 1979?
Provide a short and direct response. 0.96. What is the ratio of the Female students (as % of total students) in Nepal in 1975 to that in 1980?
Provide a short and direct response. 0.55. What is the ratio of the Female students (as % of total students) in Niger in 1975 to that in 1980?
Keep it short and to the point. 1. What is the ratio of the Female students (as % of total students) in Gambia, The in 1975 to that in 1981?
Your response must be concise. 0.96. What is the ratio of the Female students (as % of total students) in Jamaica in 1975 to that in 1981?
Your response must be concise. 1.01. What is the ratio of the Female students (as % of total students) of Nepal in 1975 to that in 1981?
Give a very brief answer. 0.58. What is the ratio of the Female students (as % of total students) of Niger in 1975 to that in 1981?
Keep it short and to the point. 1.01. What is the ratio of the Female students (as % of total students) of Gambia, The in 1976 to that in 1977?
Provide a short and direct response. 1.03. What is the ratio of the Female students (as % of total students) of Nepal in 1976 to that in 1977?
Provide a succinct answer. 0.91. What is the ratio of the Female students (as % of total students) of Niger in 1976 to that in 1977?
Offer a terse response. 1. What is the ratio of the Female students (as % of total students) in Jamaica in 1976 to that in 1978?
Offer a terse response. 1. What is the ratio of the Female students (as % of total students) of Nepal in 1976 to that in 1978?
Make the answer very short. 0.84. What is the ratio of the Female students (as % of total students) in Gambia, The in 1976 to that in 1979?
Provide a succinct answer. 1.02. What is the ratio of the Female students (as % of total students) in Jamaica in 1976 to that in 1979?
Provide a short and direct response. 1. What is the ratio of the Female students (as % of total students) of Nepal in 1976 to that in 1979?
Give a very brief answer. 0.75. What is the ratio of the Female students (as % of total students) of Niger in 1976 to that in 1979?
Give a very brief answer. 0.95. What is the ratio of the Female students (as % of total students) of Gambia, The in 1976 to that in 1980?
Make the answer very short. 1. What is the ratio of the Female students (as % of total students) in Nepal in 1976 to that in 1980?
Offer a terse response. 0.72. What is the ratio of the Female students (as % of total students) of Niger in 1976 to that in 1980?
Your answer should be compact. 0.99. What is the ratio of the Female students (as % of total students) in Gambia, The in 1976 to that in 1981?
Your answer should be very brief. 0.96. What is the ratio of the Female students (as % of total students) in Jamaica in 1976 to that in 1981?
Ensure brevity in your answer.  1.01. What is the ratio of the Female students (as % of total students) of Nepal in 1976 to that in 1981?
Give a very brief answer. 0.75. What is the ratio of the Female students (as % of total students) in Jamaica in 1977 to that in 1978?
Ensure brevity in your answer.  1. What is the ratio of the Female students (as % of total students) of Nepal in 1977 to that in 1978?
Ensure brevity in your answer.  0.93. What is the ratio of the Female students (as % of total students) of Niger in 1977 to that in 1978?
Your answer should be compact. 1. What is the ratio of the Female students (as % of total students) in Jamaica in 1977 to that in 1979?
Ensure brevity in your answer.  1. What is the ratio of the Female students (as % of total students) in Nepal in 1977 to that in 1979?
Your answer should be compact. 0.82. What is the ratio of the Female students (as % of total students) in Niger in 1977 to that in 1979?
Make the answer very short. 0.96. What is the ratio of the Female students (as % of total students) of Gambia, The in 1977 to that in 1980?
Offer a very short reply. 0.97. What is the ratio of the Female students (as % of total students) of Jamaica in 1977 to that in 1980?
Your answer should be very brief. 1. What is the ratio of the Female students (as % of total students) of Nepal in 1977 to that in 1980?
Make the answer very short. 0.79. What is the ratio of the Female students (as % of total students) of Niger in 1977 to that in 1980?
Give a very brief answer. 0.99. What is the ratio of the Female students (as % of total students) in Gambia, The in 1977 to that in 1981?
Give a very brief answer. 0.94. What is the ratio of the Female students (as % of total students) in Jamaica in 1977 to that in 1981?
Ensure brevity in your answer.  1.01. What is the ratio of the Female students (as % of total students) in Nepal in 1977 to that in 1981?
Offer a terse response. 0.82. What is the ratio of the Female students (as % of total students) in Jamaica in 1978 to that in 1979?
Provide a succinct answer. 1. What is the ratio of the Female students (as % of total students) of Nepal in 1978 to that in 1979?
Ensure brevity in your answer.  0.89. What is the ratio of the Female students (as % of total students) of Niger in 1978 to that in 1979?
Your answer should be very brief. 0.96. What is the ratio of the Female students (as % of total students) in Gambia, The in 1978 to that in 1980?
Your answer should be very brief. 0.97. What is the ratio of the Female students (as % of total students) of Jamaica in 1978 to that in 1980?
Your answer should be very brief. 1. What is the ratio of the Female students (as % of total students) of Nepal in 1978 to that in 1980?
Give a very brief answer. 0.85. What is the ratio of the Female students (as % of total students) in Gambia, The in 1978 to that in 1981?
Your answer should be compact. 0.94. What is the ratio of the Female students (as % of total students) in Nepal in 1978 to that in 1981?
Your response must be concise. 0.88. What is the ratio of the Female students (as % of total students) of Gambia, The in 1979 to that in 1980?
Give a very brief answer. 0.98. What is the ratio of the Female students (as % of total students) in Jamaica in 1979 to that in 1980?
Your answer should be compact. 1. What is the ratio of the Female students (as % of total students) of Nepal in 1979 to that in 1980?
Your response must be concise. 0.95. What is the ratio of the Female students (as % of total students) of Niger in 1979 to that in 1980?
Ensure brevity in your answer.  1.04. What is the ratio of the Female students (as % of total students) in Gambia, The in 1979 to that in 1981?
Keep it short and to the point. 0.94. What is the ratio of the Female students (as % of total students) of Nepal in 1979 to that in 1981?
Keep it short and to the point. 0.99. What is the ratio of the Female students (as % of total students) of Niger in 1979 to that in 1981?
Give a very brief answer. 1.04. What is the ratio of the Female students (as % of total students) in Gambia, The in 1980 to that in 1981?
Make the answer very short. 0.96. What is the ratio of the Female students (as % of total students) of Jamaica in 1980 to that in 1981?
Your answer should be compact. 1.01. What is the ratio of the Female students (as % of total students) in Nepal in 1980 to that in 1981?
Your answer should be very brief. 1.04. What is the ratio of the Female students (as % of total students) of Niger in 1980 to that in 1981?
Your answer should be compact. 1.01. What is the difference between the highest and the second highest Female students (as % of total students) of Gambia, The?
Your answer should be compact. 1.21. What is the difference between the highest and the second highest Female students (as % of total students) in Jamaica?
Give a very brief answer. 0.01. What is the difference between the highest and the second highest Female students (as % of total students) of Nepal?
Provide a succinct answer. 1.12. What is the difference between the highest and the second highest Female students (as % of total students) of Niger?
Keep it short and to the point. 1.3. What is the difference between the highest and the lowest Female students (as % of total students) in Gambia, The?
Offer a very short reply. 2.22. What is the difference between the highest and the lowest Female students (as % of total students) of Jamaica?
Make the answer very short. 0.38. What is the difference between the highest and the lowest Female students (as % of total students) in Nepal?
Provide a short and direct response. 12.56. What is the difference between the highest and the lowest Female students (as % of total students) of Niger?
Provide a succinct answer. 1.67. 